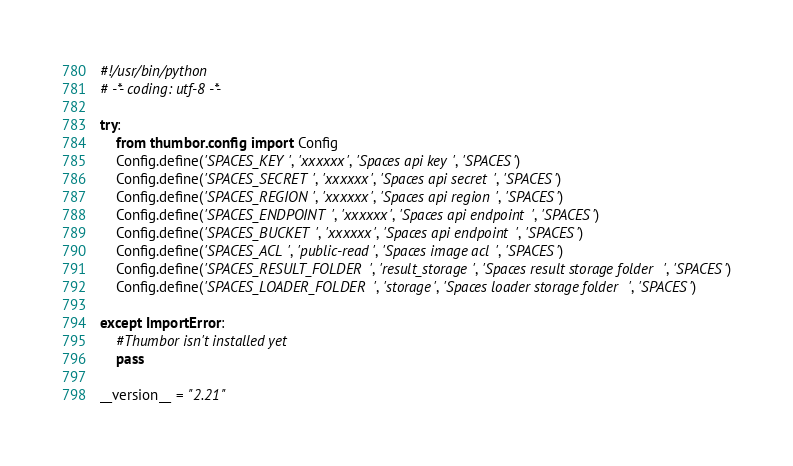<code> <loc_0><loc_0><loc_500><loc_500><_Python_>#!/usr/bin/python
# -*- coding: utf-8 -*-

try:
    from thumbor.config import Config
    Config.define('SPACES_KEY', 'xxxxxx', 'Spaces api key', 'SPACES')
    Config.define('SPACES_SECRET', 'xxxxxx', 'Spaces api secret', 'SPACES')
    Config.define('SPACES_REGION', 'xxxxxx', 'Spaces api region', 'SPACES')
    Config.define('SPACES_ENDPOINT', 'xxxxxx', 'Spaces api endpoint', 'SPACES')
    Config.define('SPACES_BUCKET', 'xxxxxx', 'Spaces api endpoint', 'SPACES')
    Config.define('SPACES_ACL', 'public-read', 'Spaces image acl', 'SPACES')
    Config.define('SPACES_RESULT_FOLDER', 'result_storage', 'Spaces result storage folder', 'SPACES')
    Config.define('SPACES_LOADER_FOLDER', 'storage', 'Spaces loader storage folder', 'SPACES')
    
except ImportError:
    #Thumbor isn't installed yet
    pass

__version__ = "2.21"</code> 